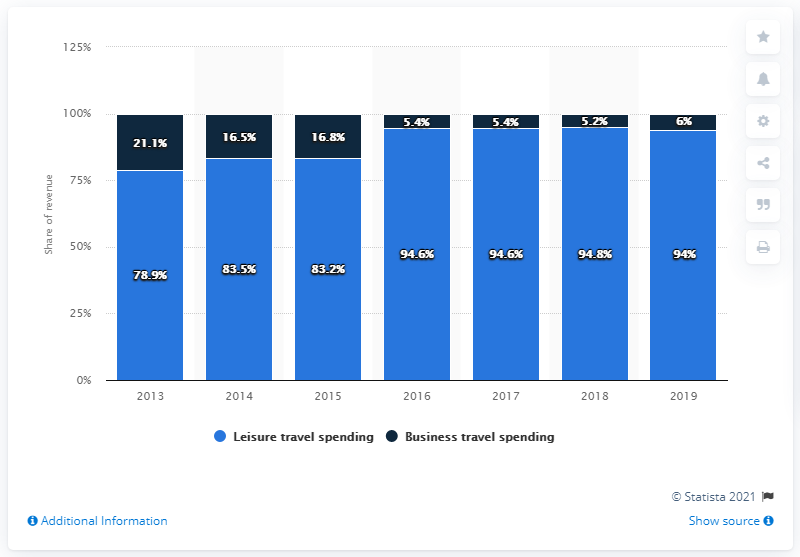Mention a couple of crucial points in this snapshot. The business travel expenses are less than 10% of the total spending for at least 4 years. In 2019, leisure travel accounted for 94.6% of the total tourism revenue generated in India. The light blue bar indicates that leisure travel spending is increasing. 